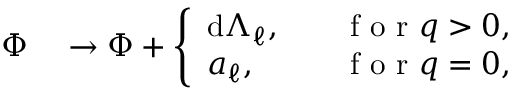<formula> <loc_0><loc_0><loc_500><loc_500>\begin{array} { r l } { \Phi } & \to \Phi + \left \{ \begin{array} { l l } { d \Lambda _ { \ell } , } & { \quad f o r q > 0 , } \\ { a _ { \ell } , } & { \quad f o r q = 0 , } \end{array} } \end{array}</formula> 